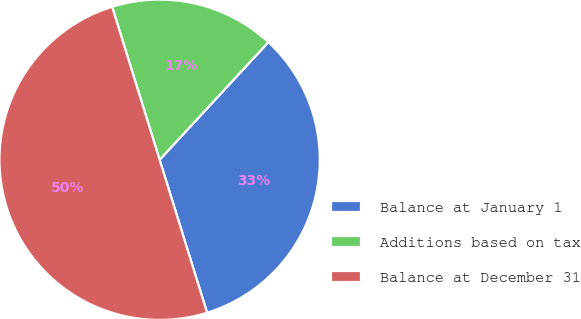<chart> <loc_0><loc_0><loc_500><loc_500><pie_chart><fcel>Balance at January 1<fcel>Additions based on tax<fcel>Balance at December 31<nl><fcel>33.33%<fcel>16.67%<fcel>50.0%<nl></chart> 